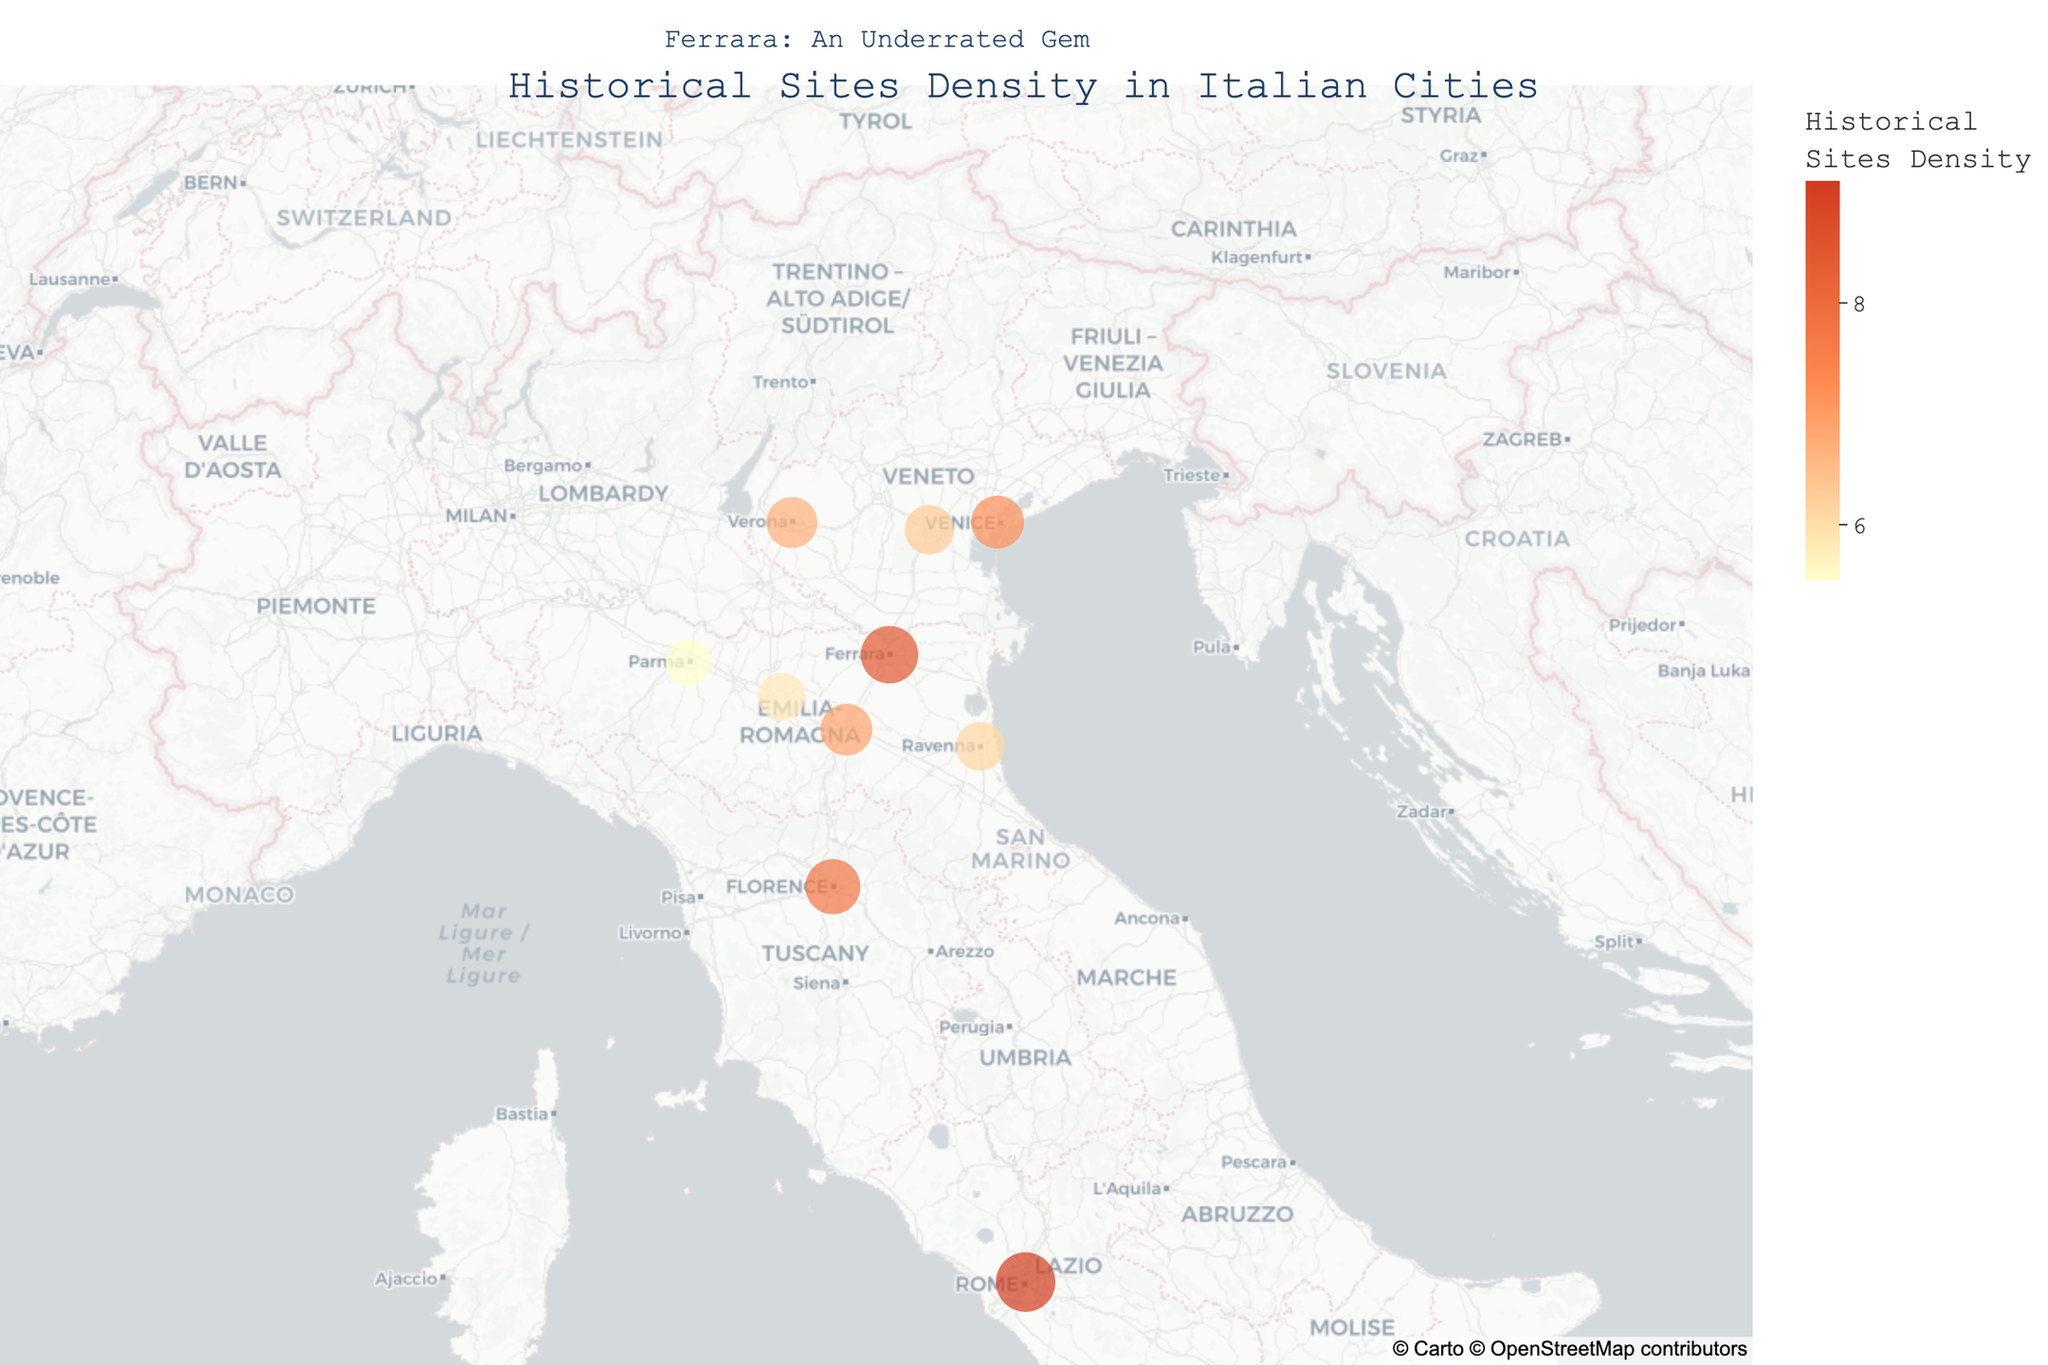What is the title of the figure? The title is usually placed at the top of the figure. In this case, it is clearly written over the map.
Answer: Historical Sites Density in Italian Cities What is the major attraction in Ferrara? By hovering over Ferrara on the map or looking at the hover data, you can see the major attraction listed.
Answer: Castello Estense How many cities have a higher Historical Sites Density than Ferrara? Ferrara has a Historical Sites Density of 8.5. Only Rome has a higher density at 9.1. This can be quickly checked by comparing the sizes of the circles.
Answer: 1 Which city has the smallest Historical Sites Density? By comparing the size of circles and hover data on the map, the smallest circle and its hover data show Parma has the smallest density.
Answer: Parma Compare the Historical Sites Density between Ferrara and Venice. By looking at the circles' sizes and hover data, Ferrara has a density of 8.5, and Venice has 7.2. Therefore, Ferrara has a higher density than Venice.
Answer: Ferrara is higher What is the total Historical Sites Density for Parma, Modena, and Ravenna combined? Gather the densities from the hover data: Parma (5.5), Modena (5.8), and Ravenna (6.1). Summing them up gives: 5.5 + 5.8 + 6.1 = 17.4
Answer: 17.4 Which city has the closest Historical Sites Density to Florence? Florence has a density of 7.8. By comparing other cities' densities, Venice with 7.2 is the closest.
Answer: Venice How does the color scale help to interpret the data? The color scale from light yellow to deep red indicates increasing density, allowing a quick visual cue without needing specific values immediately. Ferrara is shown in a darker shade, indicating a high density.
Answer: Visual indication of increasing density Where is the annotation about Ferrara located on the figure? The annotation is placed above the map area, as stated: "Ferrara: An Underrated Gem". It is centered in the new map area at the top part.
Answer: Above the map What is the difference in Historical Sites Density between the highest and lowest density cities? The highest density is in Rome (9.1) and the lowest in Parma (5.5). The difference is calculated as 9.1 - 5.5 = 3.6
Answer: 3.6 